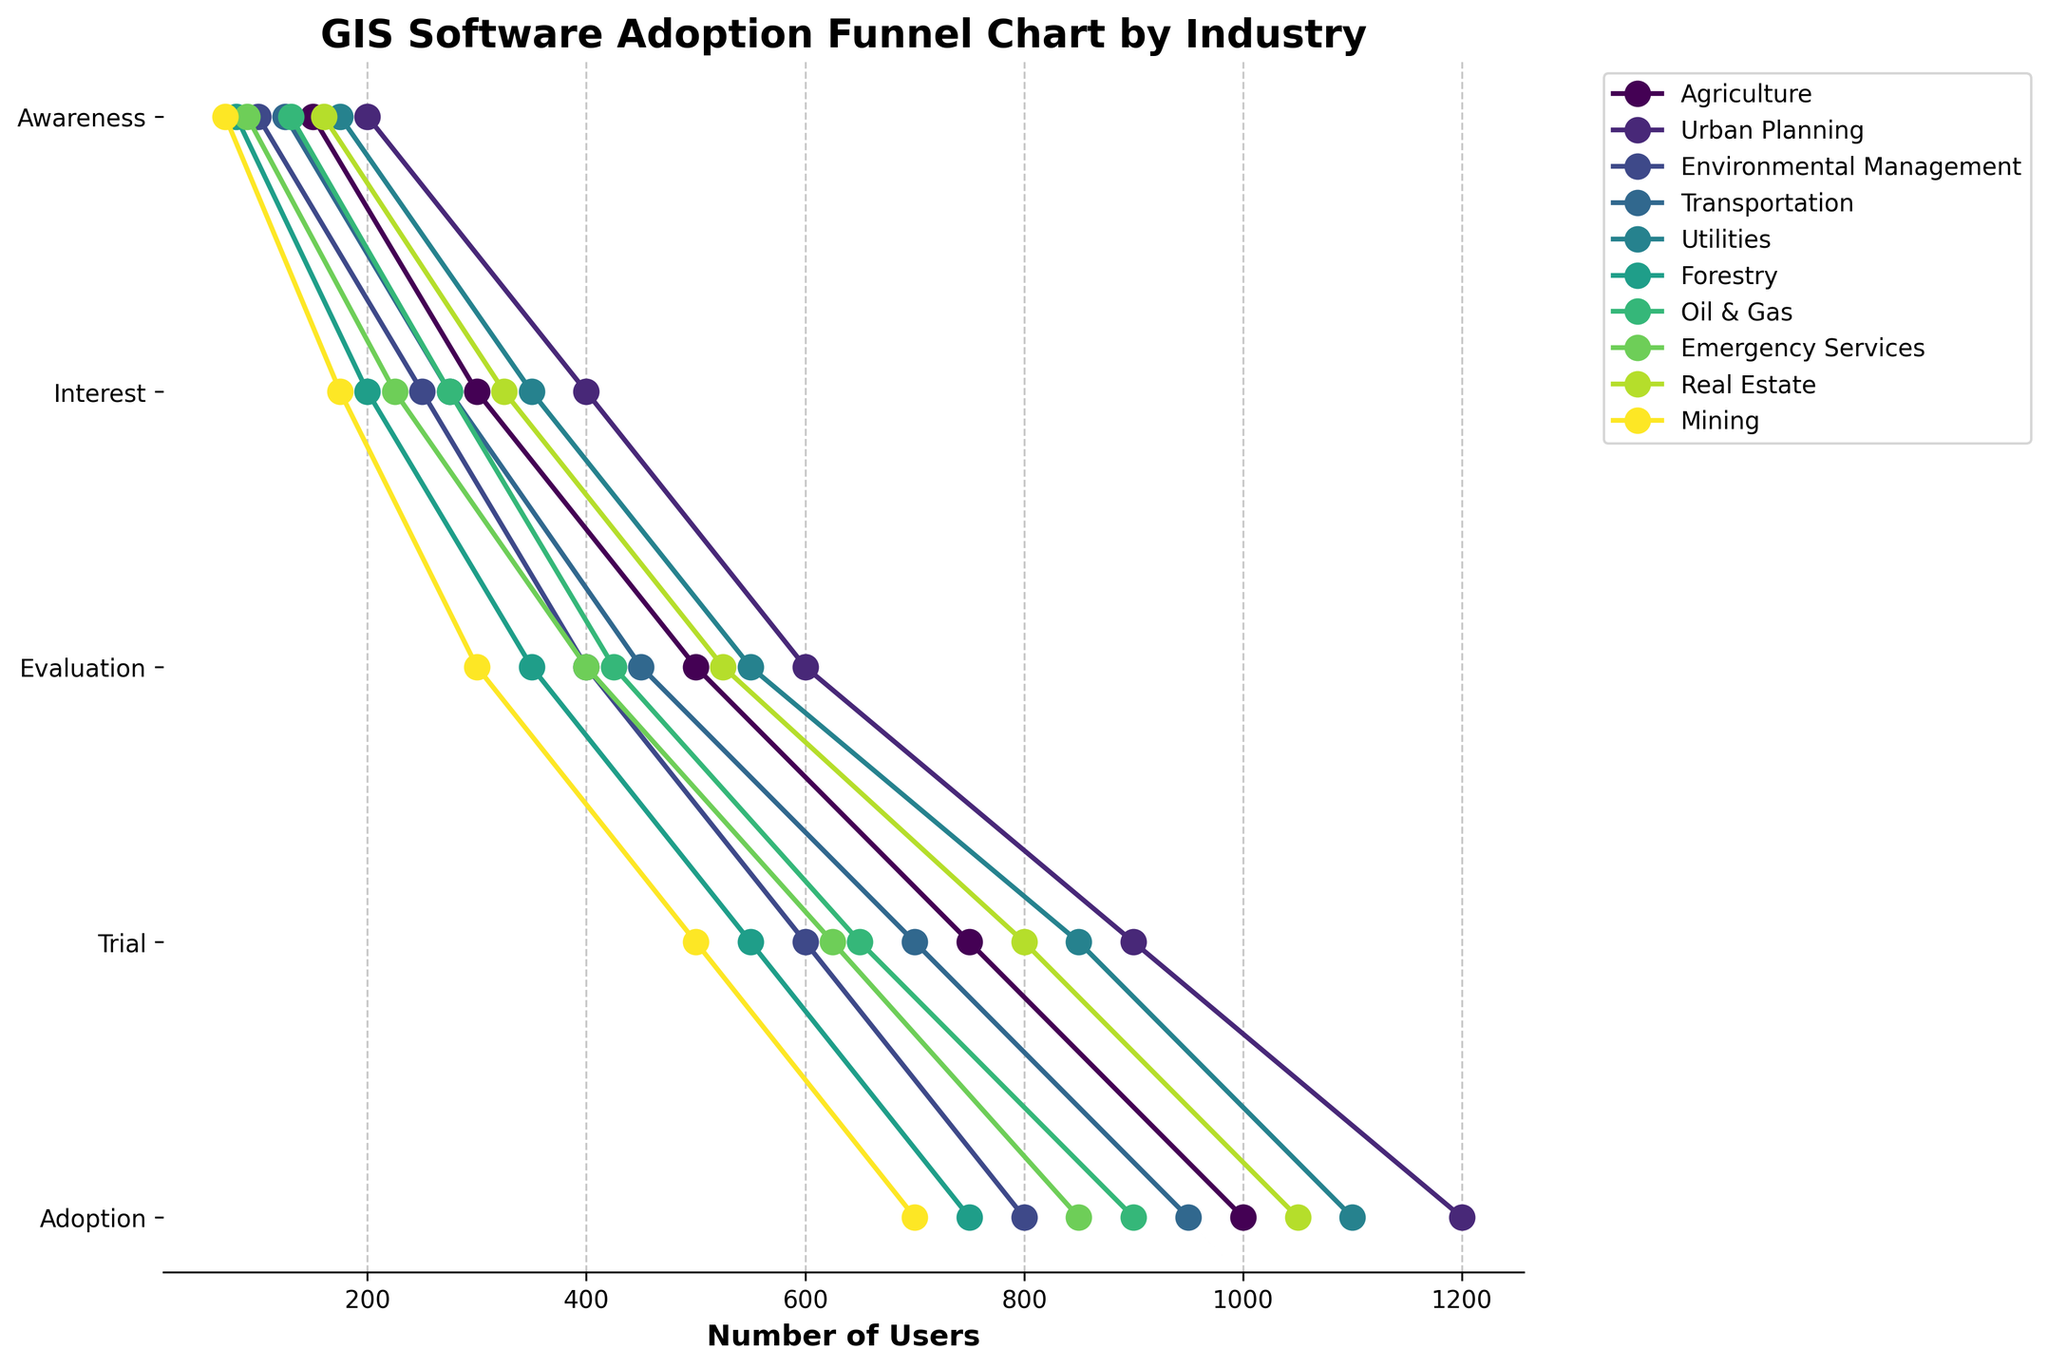What is the title of the funnel chart? The title of the funnel chart is usually displayed at the top of the figure to provide an overview of what the visualization represents. In this plot, the title helps to understand that the chart is about GIS software adoption in different industries.
Answer: GIS Software Adoption Funnel Chart by Industry Which industry has the highest number of users in the 'Awareness' stage? Looking at the plot from left to right, the industry with the highest initial data point (on the x-axis) at the 'Awareness' stage can be identified.
Answer: Urban Planning What is the drop-off rate from 'Interest' to 'Adoption' for the Agriculture industry? Subtract the number of users in the 'Adoption' stage from those in the 'Interest' stage for the Agriculture industry. This tells us how many users were lost between these two stages. The difference is then converted into a rate relative to the initial 'Interest' number.
Answer: 600 (750 - 150) How does the number of users in the 'Trial' stage for Transportation compare with those of the Utilities industry at the same stage? Identify the number of users in the 'Trial' stage for both the Transportation and Utilities industries and compare the two values directly.
Answer: Transportation has fewer users (275 compared to 350) Which industry shows the smallest decline in user engagement from the 'Awareness' to the 'Interest' stage? Calculate the difference in user numbers between the 'Awareness' and 'Interest' stages for each industry, and identify the industry with the smallest value.
Answer: Urban Planning What is the relative proportion of users reaching the 'Adoption' stage out of those initially aware (Awareness stage) for the Forestry industry? Divide the number of users who reached 'Adoption' by the number of users initially in the 'Awareness' stage for the Forestry industry, then multiply by 100 to get the percentage.
Answer: 10.67% Compare the total number of users in the 'Evaluation' stage across all industries. Sum the number of users in the 'Evaluation' stage for each industry to get the total.
Answer: 4,500 (500 + 600 + 400 + 450 + 550 + 350 + 425 + 400 + 525 + 300) What percentage of Real Estate users transition from 'Trial' to 'Adoption'? Divide the number of users in the 'Adoption' stage by the number of users in the 'Trial' stage for the Real Estate industry, then multiply by 100 to get the percentage.
Answer: 49.23% (160/325*100) Which industry has the most consistent decline in user numbers across the stages from 'Awareness' to 'Adoption'? A consistent decline means that the decrease in user numbers between each stage is relatively uniform. Look across the values for each industry and identify the one with the smallest fluctuation between stages.
Answer: Urban Planning 